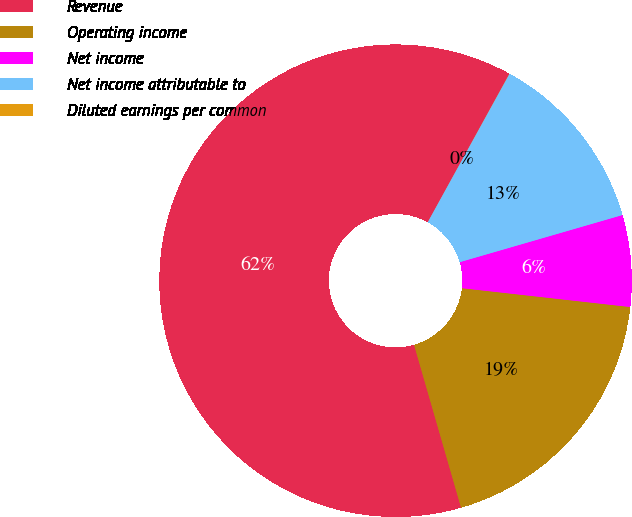Convert chart. <chart><loc_0><loc_0><loc_500><loc_500><pie_chart><fcel>Revenue<fcel>Operating income<fcel>Net income<fcel>Net income attributable to<fcel>Diluted earnings per common<nl><fcel>62.47%<fcel>18.75%<fcel>6.26%<fcel>12.5%<fcel>0.01%<nl></chart> 